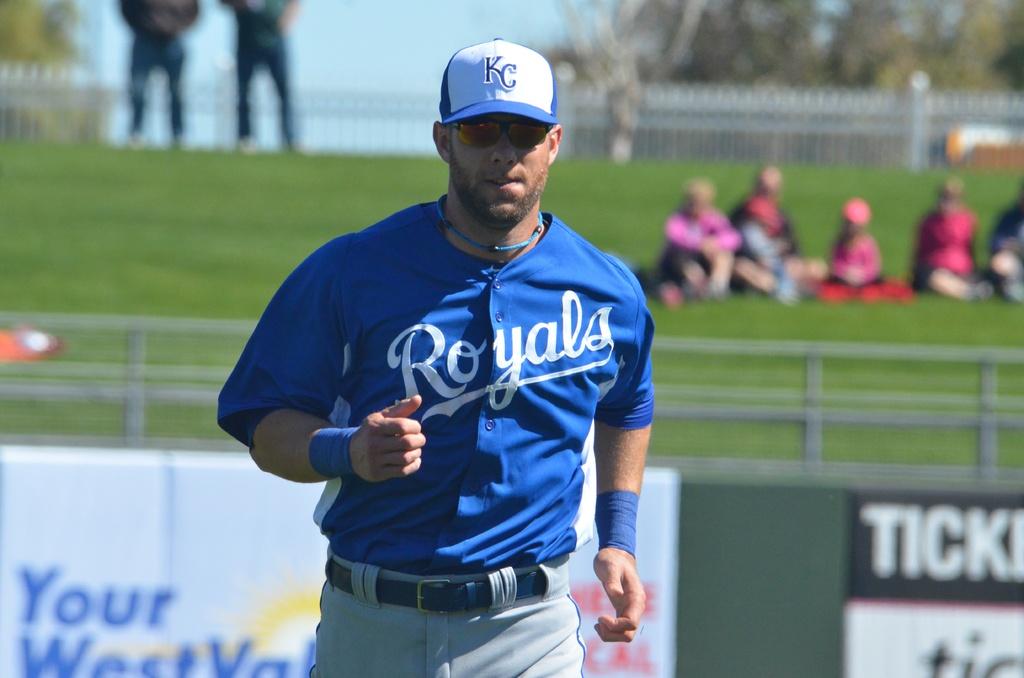What city is on the hat?
Give a very brief answer. Kc. 